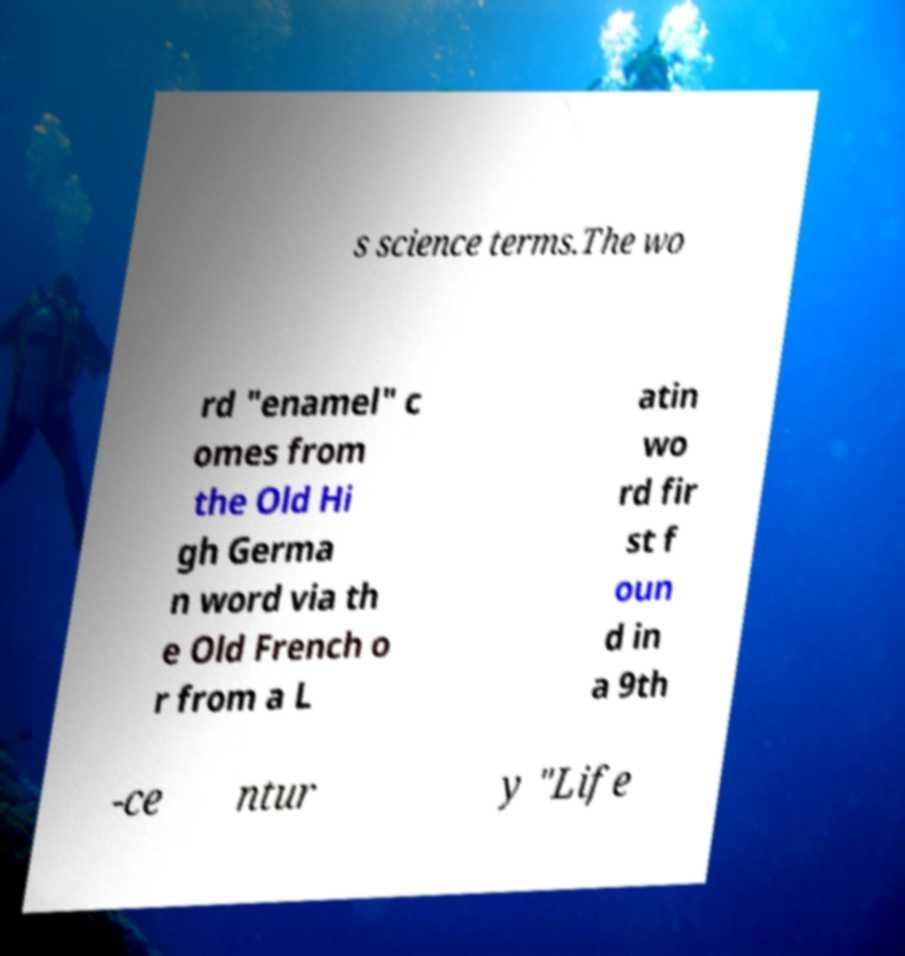Could you extract and type out the text from this image? s science terms.The wo rd "enamel" c omes from the Old Hi gh Germa n word via th e Old French o r from a L atin wo rd fir st f oun d in a 9th -ce ntur y "Life 